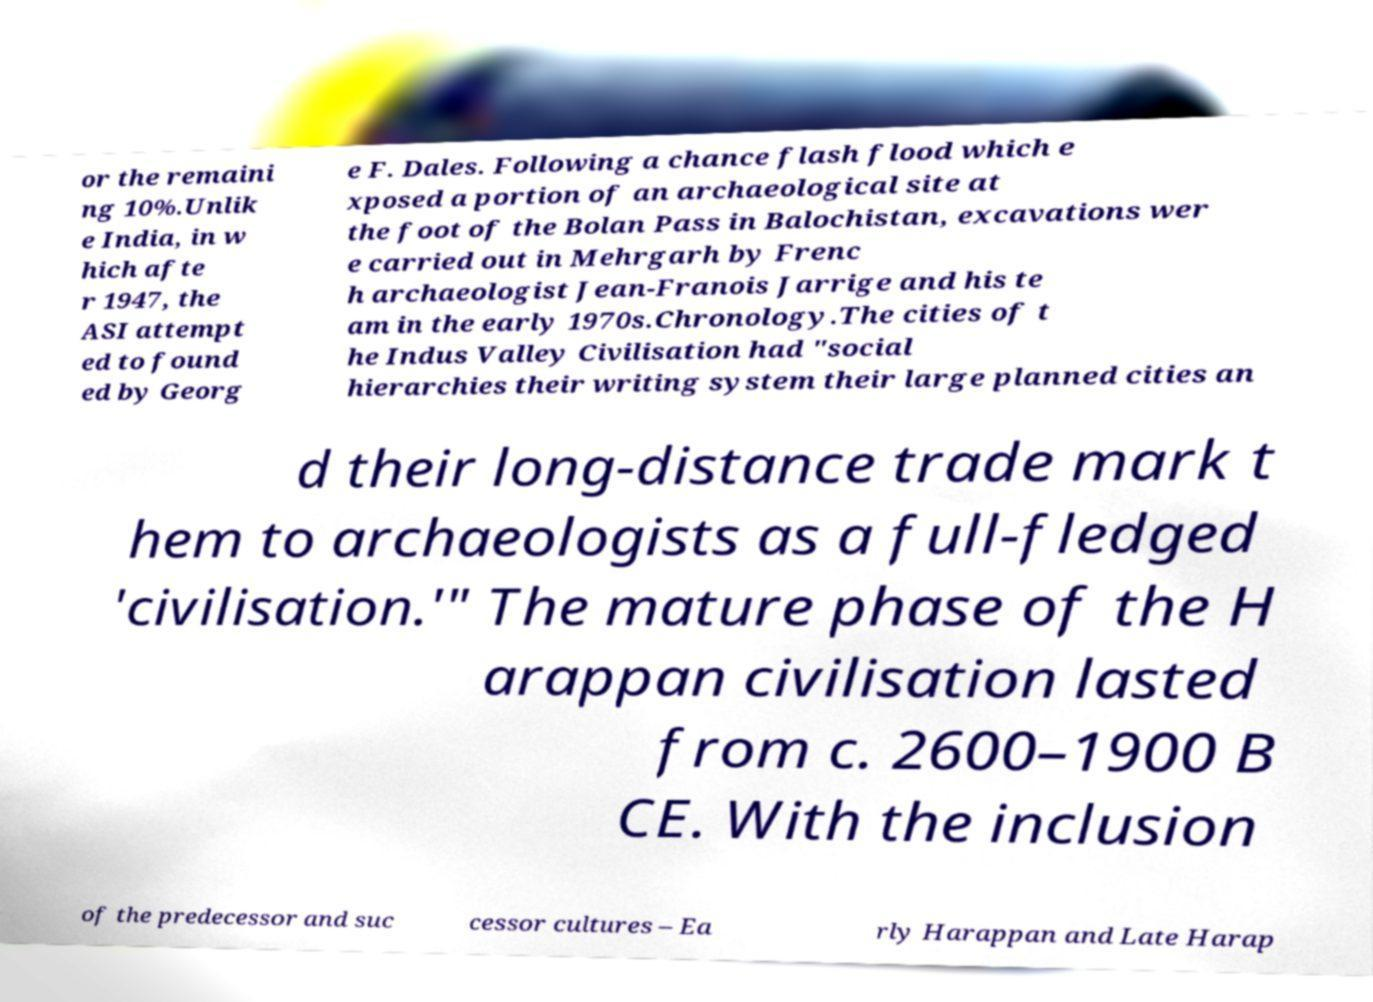Can you accurately transcribe the text from the provided image for me? or the remaini ng 10%.Unlik e India, in w hich afte r 1947, the ASI attempt ed to found ed by Georg e F. Dales. Following a chance flash flood which e xposed a portion of an archaeological site at the foot of the Bolan Pass in Balochistan, excavations wer e carried out in Mehrgarh by Frenc h archaeologist Jean-Franois Jarrige and his te am in the early 1970s.Chronology.The cities of t he Indus Valley Civilisation had "social hierarchies their writing system their large planned cities an d their long-distance trade mark t hem to archaeologists as a full-fledged 'civilisation.'" The mature phase of the H arappan civilisation lasted from c. 2600–1900 B CE. With the inclusion of the predecessor and suc cessor cultures – Ea rly Harappan and Late Harap 